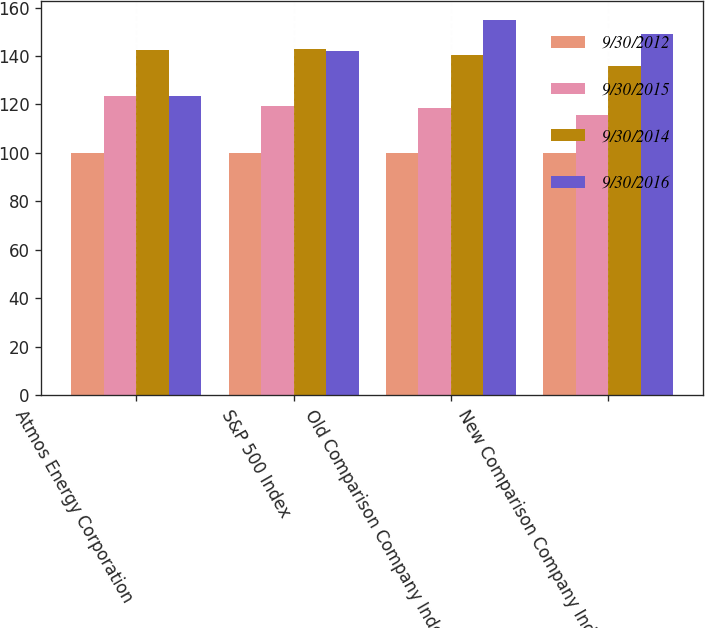<chart> <loc_0><loc_0><loc_500><loc_500><stacked_bar_chart><ecel><fcel>Atmos Energy Corporation<fcel>S&P 500 Index<fcel>Old Comparison Company Index<fcel>New Comparison Company Index<nl><fcel>9/30/2012<fcel>100<fcel>100<fcel>100<fcel>100<nl><fcel>9/30/2015<fcel>123.32<fcel>119.34<fcel>118.55<fcel>115.8<nl><fcel>9/30/2014<fcel>142.46<fcel>142.89<fcel>140.49<fcel>135.84<nl><fcel>9/30/2016<fcel>123.32<fcel>142.02<fcel>154.76<fcel>149.18<nl></chart> 